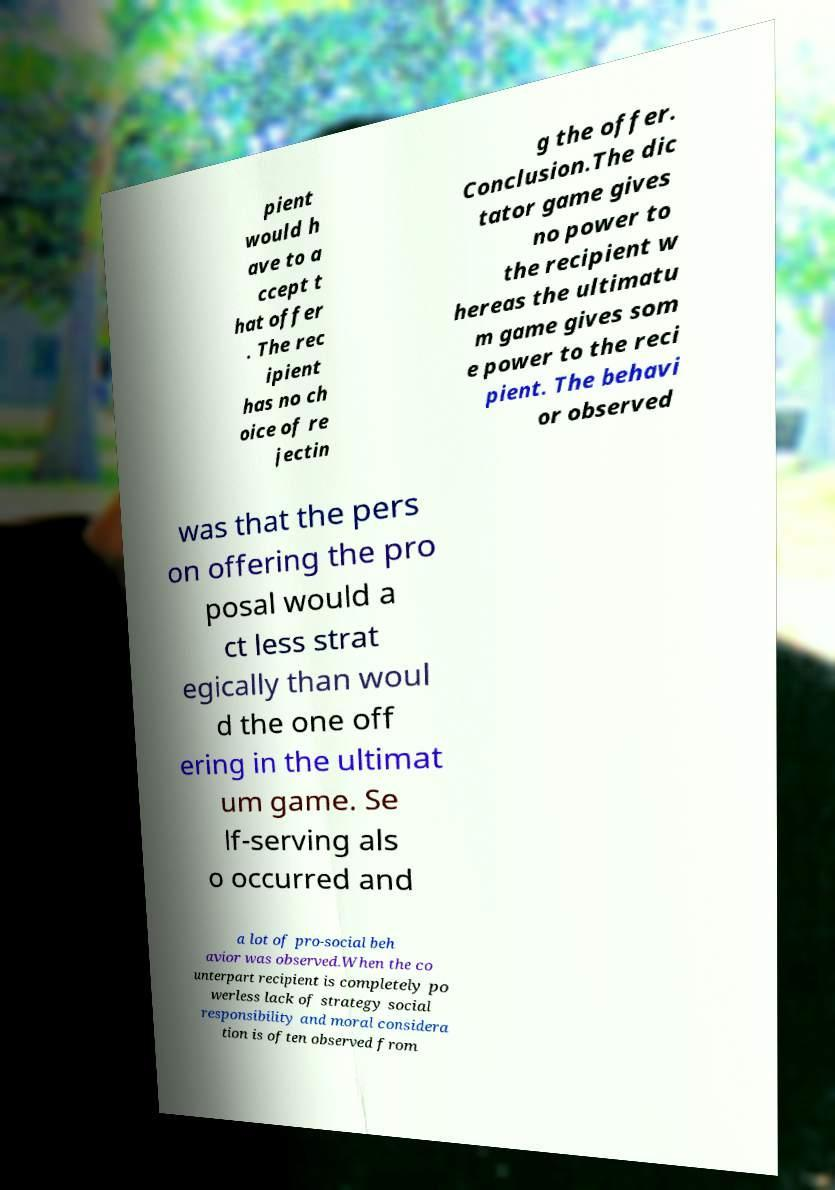There's text embedded in this image that I need extracted. Can you transcribe it verbatim? pient would h ave to a ccept t hat offer . The rec ipient has no ch oice of re jectin g the offer. Conclusion.The dic tator game gives no power to the recipient w hereas the ultimatu m game gives som e power to the reci pient. The behavi or observed was that the pers on offering the pro posal would a ct less strat egically than woul d the one off ering in the ultimat um game. Se lf-serving als o occurred and a lot of pro-social beh avior was observed.When the co unterpart recipient is completely po werless lack of strategy social responsibility and moral considera tion is often observed from 